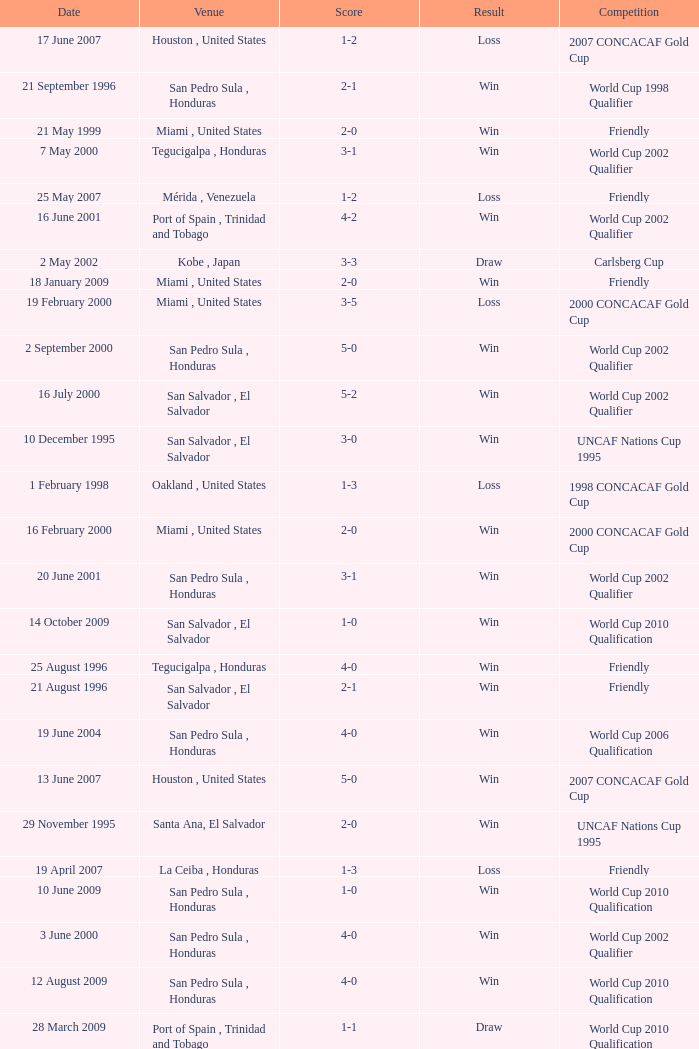What is the venue for the friendly competition and score of 4-0? Tegucigalpa , Honduras. 